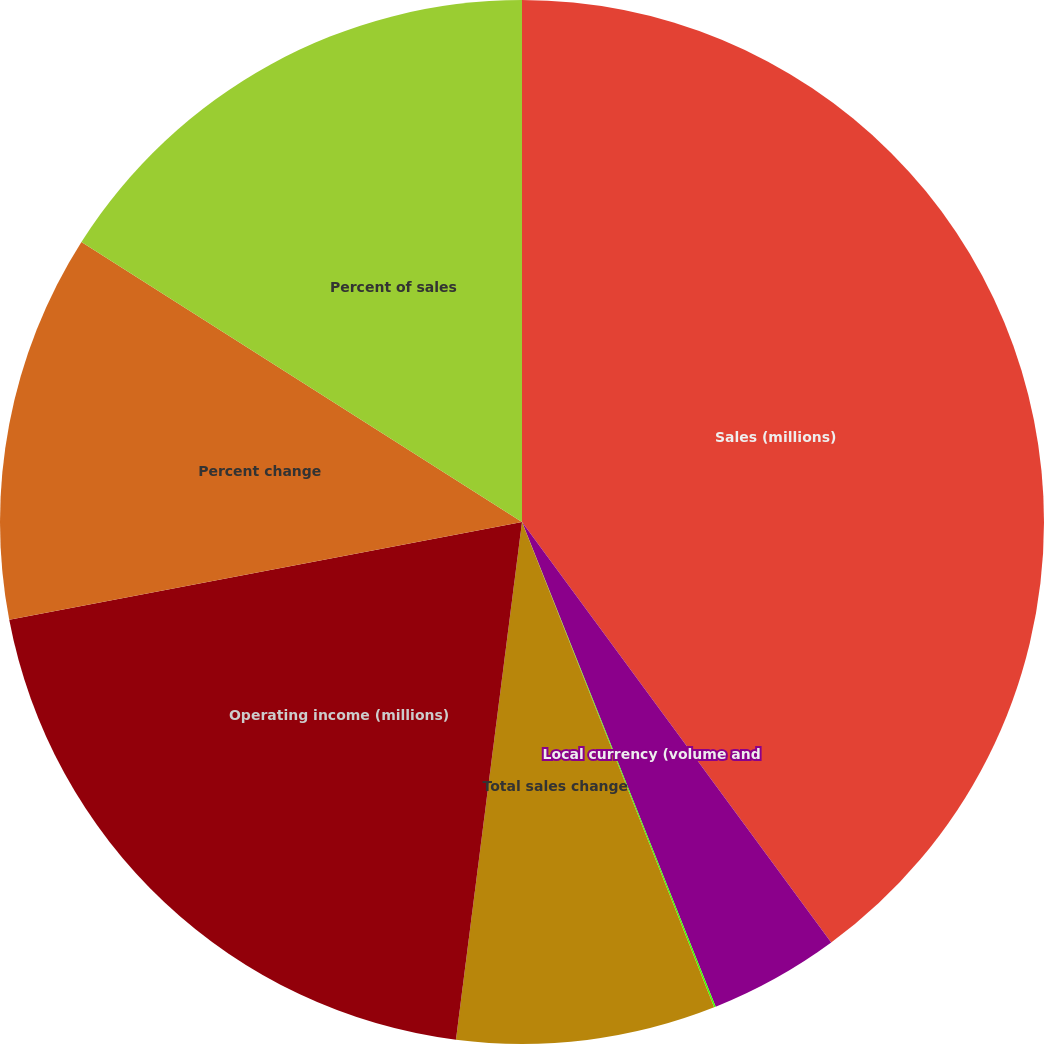Convert chart. <chart><loc_0><loc_0><loc_500><loc_500><pie_chart><fcel>Sales (millions)<fcel>Local currency (volume and<fcel>Translation<fcel>Total sales change<fcel>Operating income (millions)<fcel>Percent change<fcel>Percent of sales<nl><fcel>39.91%<fcel>4.04%<fcel>0.05%<fcel>8.02%<fcel>19.98%<fcel>12.01%<fcel>15.99%<nl></chart> 